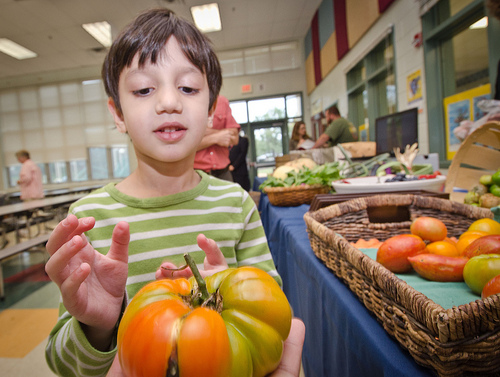<image>
Can you confirm if the boy is under the pumpkin? No. The boy is not positioned under the pumpkin. The vertical relationship between these objects is different. 